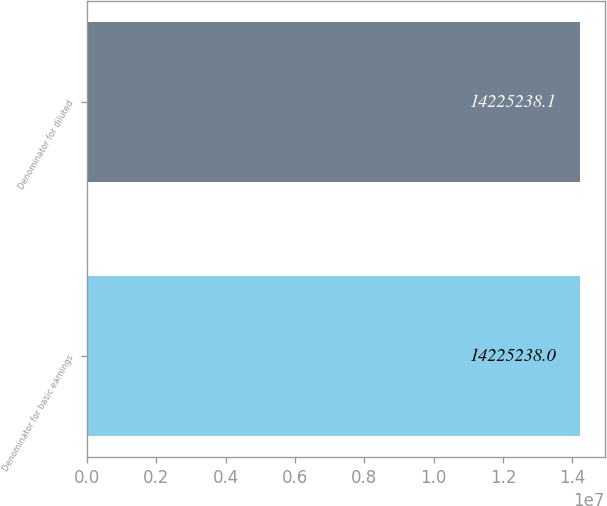Convert chart. <chart><loc_0><loc_0><loc_500><loc_500><bar_chart><fcel>Denominator for basic earnings<fcel>Denominator for diluted<nl><fcel>1.42252e+07<fcel>1.42252e+07<nl></chart> 